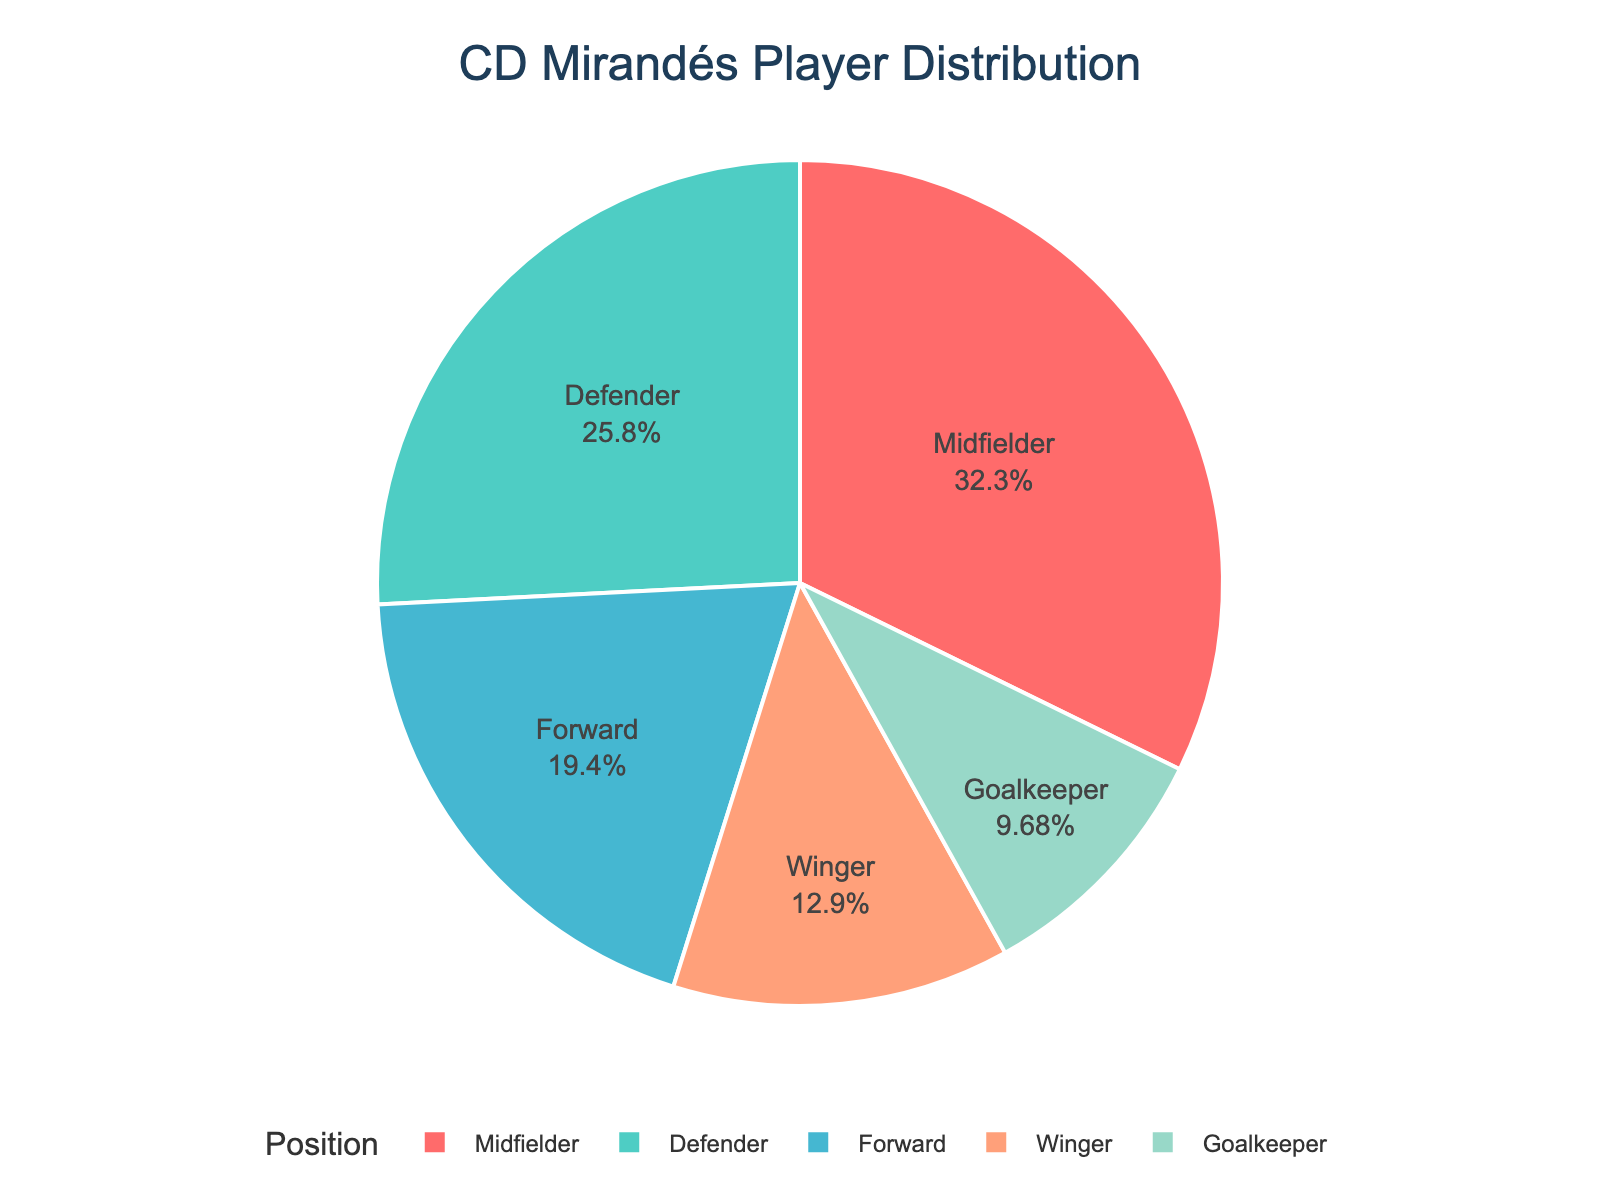what percentage of players are midfielders? The midfielder section of the pie chart shows a specific percentage. By examining the chart, we can directly see this percentage.
Answer: 31.25% which position has the fewest players? From the pie chart, we can see that the section with the smallest size represents the position with the fewest players.
Answer: Goalkeeper how many more defenders than goalkeepers are there? The pie chart shows 8 defenders and 3 goalkeepers. Subtracting the number of goalkeepers from defenders gives us the difference. 8 - 3 = 5
Answer: 5 which positions have a percentage greater than the average percentage per position? First, calculate the average percentage per position by dividing 100% by the number of positions (5). 100% / 5 = 20%. Next, identify the positions in the pie chart with percentages greater than 20%.
Answer: Midfielder, Defender what are the colors representing goalkeepers and wingers? By examining the pie chart, we can see the color associated with goalkeepers and wingers.
Answer: Goalkeepers: red, Wingers: aqua are there more midfielders or forwards, and by how many? The pie chart shows 10 midfielders and 6 forwards. By subtracting the number of forwards from midfielders, we find the difference. 10 - 6 = 4
Answer: Midfielders by 4 what is the ratio of defenders to the total number of players? To find the ratio, divide the number of defenders by the total number of players. The total number of players is 31. The number of defenders is 8. 8 / 31 = 0.258.
Answer: 0.258 what positions make up over 60% of the total player distribution? Examine the pie chart and add the percentages of each position until the cumulative percentage exceeds 60%.
Answer: Midfielders, Defenders 